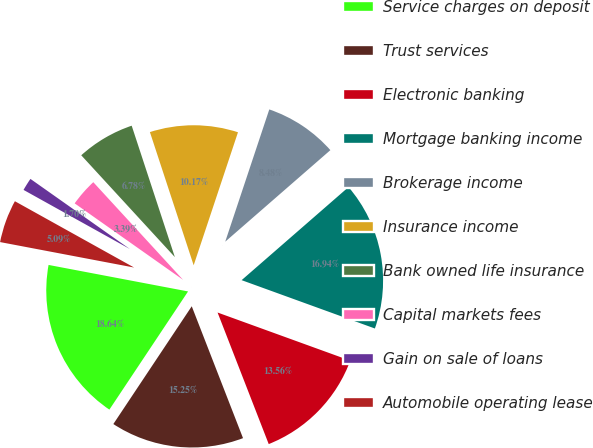Convert chart to OTSL. <chart><loc_0><loc_0><loc_500><loc_500><pie_chart><fcel>Service charges on deposit<fcel>Trust services<fcel>Electronic banking<fcel>Mortgage banking income<fcel>Brokerage income<fcel>Insurance income<fcel>Bank owned life insurance<fcel>Capital markets fees<fcel>Gain on sale of loans<fcel>Automobile operating lease<nl><fcel>18.64%<fcel>15.25%<fcel>13.56%<fcel>16.94%<fcel>8.48%<fcel>10.17%<fcel>6.78%<fcel>3.39%<fcel>1.7%<fcel>5.09%<nl></chart> 